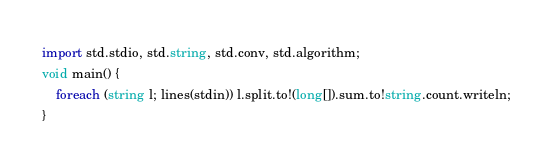<code> <loc_0><loc_0><loc_500><loc_500><_D_>import std.stdio, std.string, std.conv, std.algorithm;
void main() {
	foreach (string l; lines(stdin)) l.split.to!(long[]).sum.to!string.count.writeln;
}</code> 